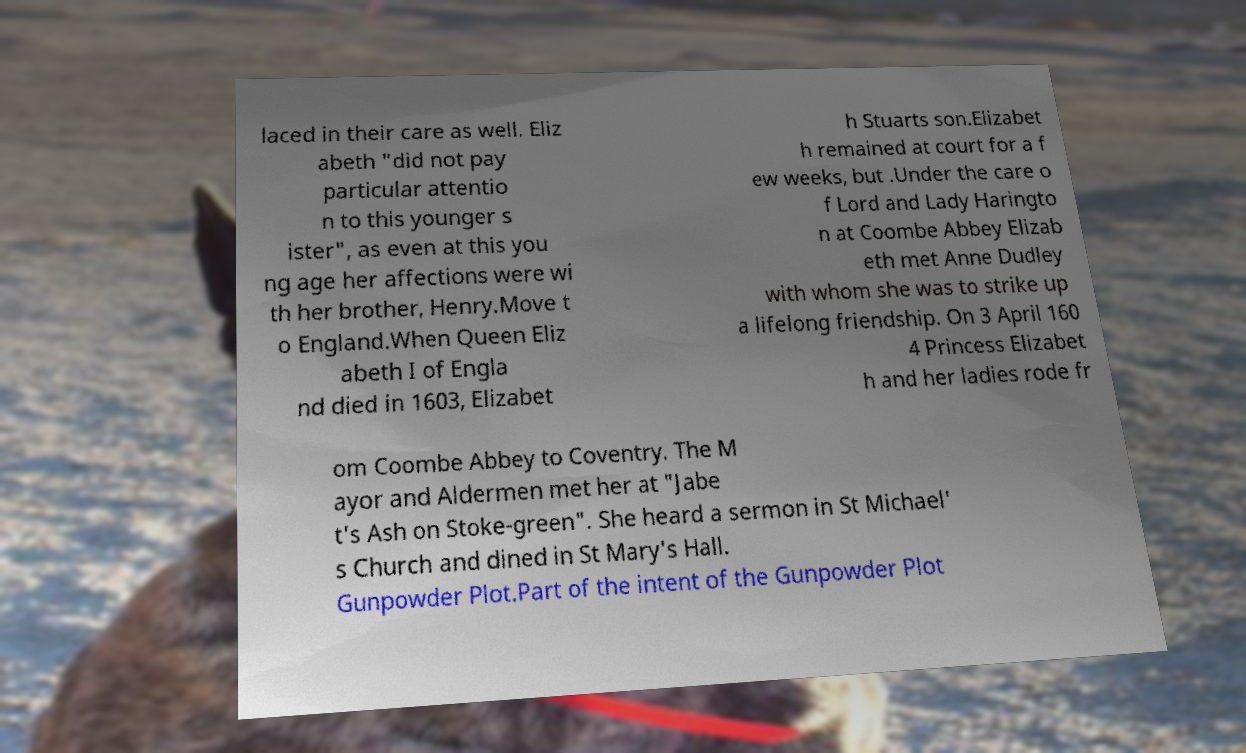Could you assist in decoding the text presented in this image and type it out clearly? laced in their care as well. Eliz abeth "did not pay particular attentio n to this younger s ister", as even at this you ng age her affections were wi th her brother, Henry.Move t o England.When Queen Eliz abeth I of Engla nd died in 1603, Elizabet h Stuarts son.Elizabet h remained at court for a f ew weeks, but .Under the care o f Lord and Lady Haringto n at Coombe Abbey Elizab eth met Anne Dudley with whom she was to strike up a lifelong friendship. On 3 April 160 4 Princess Elizabet h and her ladies rode fr om Coombe Abbey to Coventry. The M ayor and Aldermen met her at "Jabe t's Ash on Stoke-green". She heard a sermon in St Michael' s Church and dined in St Mary's Hall. Gunpowder Plot.Part of the intent of the Gunpowder Plot 